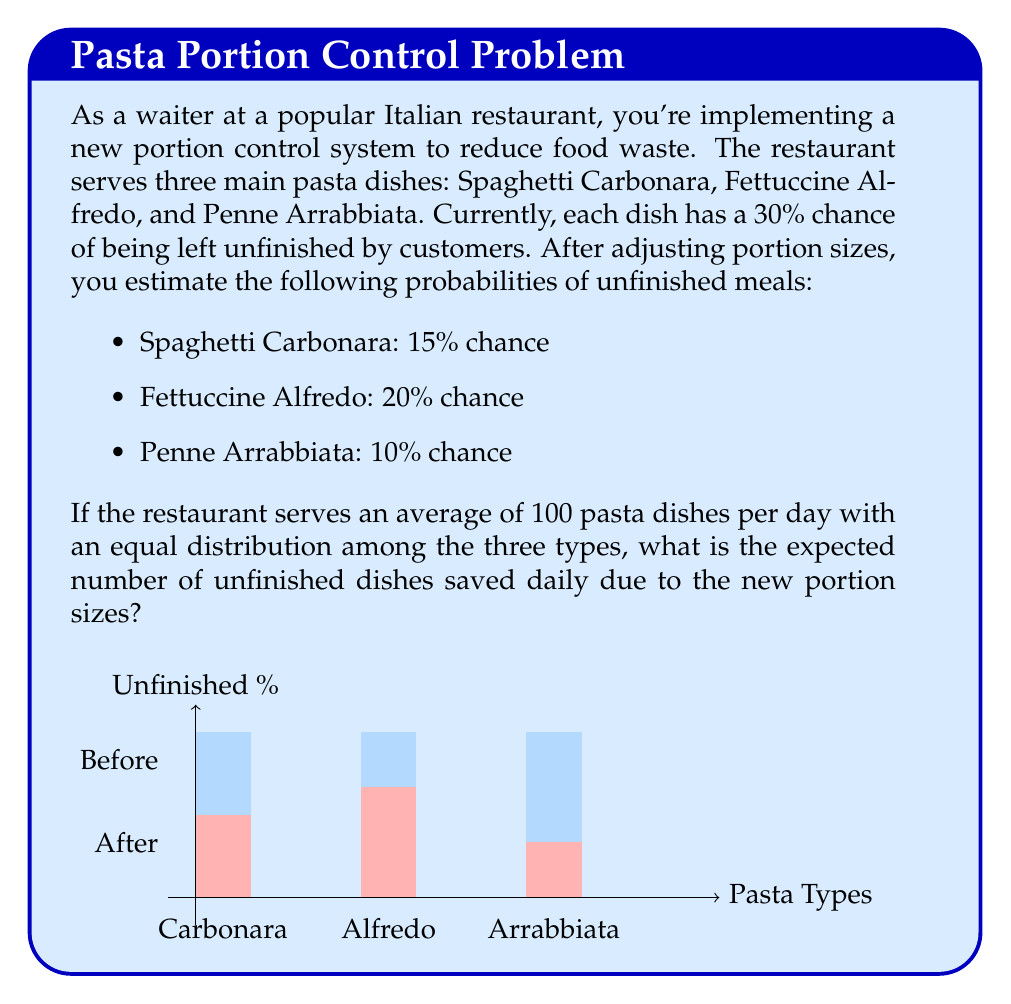What is the answer to this math problem? Let's approach this step-by-step:

1) First, we need to calculate the average number of each pasta dish served daily:
   $\frac{100 \text{ dishes}}{3 \text{ types}} = \frac{100}{3} \approx 33.33$ dishes of each type

2) Now, let's calculate the expected number of unfinished dishes before and after the portion size adjustment:

   Before:
   - Expected unfinished dishes = $100 \times 30\% = 30$ dishes

   After:
   - Spaghetti Carbonara: $\frac{100}{3} \times 15\% = 5$ dishes
   - Fettuccine Alfredo: $\frac{100}{3} \times 20\% = \frac{20}{3} \approx 6.67$ dishes
   - Penne Arrabbiata: $\frac{100}{3} \times 10\% = \frac{10}{3} \approx 3.33$ dishes

3) Total expected unfinished dishes after adjustment:
   $5 + \frac{20}{3} + \frac{10}{3} = 5 + 10 = 15$ dishes

4) To find the number of unfinished dishes saved:
   Dishes saved = Dishes unfinished before - Dishes unfinished after
   $30 - 15 = 15$ dishes

Therefore, the expected number of unfinished dishes saved daily is 15.
Answer: 15 dishes 